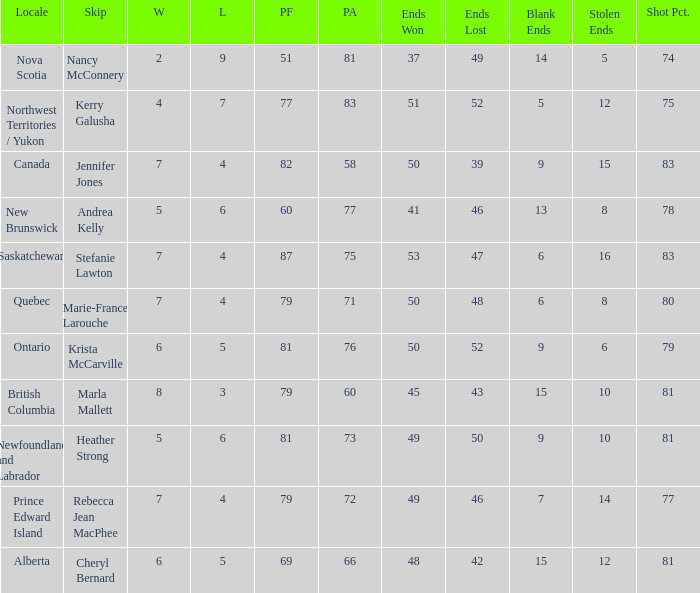Where was the shot pct 78? New Brunswick. 